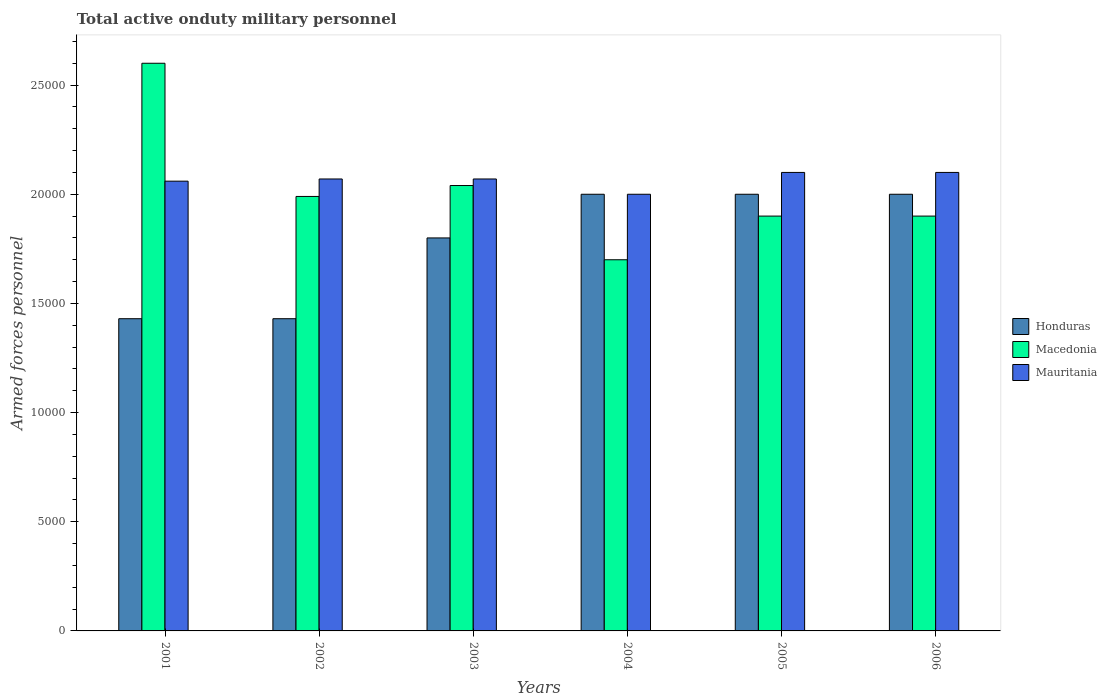How many groups of bars are there?
Provide a succinct answer. 6. How many bars are there on the 3rd tick from the left?
Offer a terse response. 3. How many bars are there on the 1st tick from the right?
Ensure brevity in your answer.  3. What is the number of armed forces personnel in Mauritania in 2002?
Offer a terse response. 2.07e+04. Across all years, what is the maximum number of armed forces personnel in Honduras?
Keep it short and to the point. 2.00e+04. Across all years, what is the minimum number of armed forces personnel in Honduras?
Make the answer very short. 1.43e+04. What is the total number of armed forces personnel in Honduras in the graph?
Provide a short and direct response. 1.07e+05. What is the difference between the number of armed forces personnel in Mauritania in 2002 and that in 2004?
Ensure brevity in your answer.  700. What is the difference between the number of armed forces personnel in Mauritania in 2006 and the number of armed forces personnel in Honduras in 2004?
Make the answer very short. 1000. What is the average number of armed forces personnel in Honduras per year?
Provide a succinct answer. 1.78e+04. In the year 2001, what is the difference between the number of armed forces personnel in Honduras and number of armed forces personnel in Macedonia?
Provide a succinct answer. -1.17e+04. What is the ratio of the number of armed forces personnel in Macedonia in 2002 to that in 2006?
Your answer should be very brief. 1.05. Is the number of armed forces personnel in Macedonia in 2002 less than that in 2006?
Ensure brevity in your answer.  No. Is the difference between the number of armed forces personnel in Honduras in 2002 and 2005 greater than the difference between the number of armed forces personnel in Macedonia in 2002 and 2005?
Keep it short and to the point. No. What is the difference between the highest and the second highest number of armed forces personnel in Macedonia?
Provide a succinct answer. 5600. What is the difference between the highest and the lowest number of armed forces personnel in Honduras?
Your response must be concise. 5700. Is the sum of the number of armed forces personnel in Mauritania in 2001 and 2004 greater than the maximum number of armed forces personnel in Macedonia across all years?
Your answer should be very brief. Yes. What does the 2nd bar from the left in 2002 represents?
Your response must be concise. Macedonia. What does the 3rd bar from the right in 2003 represents?
Offer a very short reply. Honduras. How many bars are there?
Keep it short and to the point. 18. Are all the bars in the graph horizontal?
Your answer should be compact. No. Are the values on the major ticks of Y-axis written in scientific E-notation?
Offer a terse response. No. Does the graph contain grids?
Keep it short and to the point. No. Where does the legend appear in the graph?
Provide a short and direct response. Center right. How many legend labels are there?
Your answer should be very brief. 3. What is the title of the graph?
Keep it short and to the point. Total active onduty military personnel. Does "Tonga" appear as one of the legend labels in the graph?
Your answer should be compact. No. What is the label or title of the X-axis?
Your response must be concise. Years. What is the label or title of the Y-axis?
Provide a short and direct response. Armed forces personnel. What is the Armed forces personnel of Honduras in 2001?
Provide a succinct answer. 1.43e+04. What is the Armed forces personnel of Macedonia in 2001?
Give a very brief answer. 2.60e+04. What is the Armed forces personnel of Mauritania in 2001?
Make the answer very short. 2.06e+04. What is the Armed forces personnel of Honduras in 2002?
Your answer should be very brief. 1.43e+04. What is the Armed forces personnel of Macedonia in 2002?
Your answer should be compact. 1.99e+04. What is the Armed forces personnel in Mauritania in 2002?
Offer a terse response. 2.07e+04. What is the Armed forces personnel in Honduras in 2003?
Your answer should be compact. 1.80e+04. What is the Armed forces personnel in Macedonia in 2003?
Offer a very short reply. 2.04e+04. What is the Armed forces personnel in Mauritania in 2003?
Your answer should be very brief. 2.07e+04. What is the Armed forces personnel in Macedonia in 2004?
Make the answer very short. 1.70e+04. What is the Armed forces personnel of Macedonia in 2005?
Your answer should be very brief. 1.90e+04. What is the Armed forces personnel in Mauritania in 2005?
Your answer should be compact. 2.10e+04. What is the Armed forces personnel in Honduras in 2006?
Provide a short and direct response. 2.00e+04. What is the Armed forces personnel of Macedonia in 2006?
Make the answer very short. 1.90e+04. What is the Armed forces personnel in Mauritania in 2006?
Your response must be concise. 2.10e+04. Across all years, what is the maximum Armed forces personnel of Honduras?
Provide a succinct answer. 2.00e+04. Across all years, what is the maximum Armed forces personnel of Macedonia?
Provide a succinct answer. 2.60e+04. Across all years, what is the maximum Armed forces personnel of Mauritania?
Provide a succinct answer. 2.10e+04. Across all years, what is the minimum Armed forces personnel of Honduras?
Offer a terse response. 1.43e+04. Across all years, what is the minimum Armed forces personnel of Macedonia?
Provide a succinct answer. 1.70e+04. What is the total Armed forces personnel of Honduras in the graph?
Keep it short and to the point. 1.07e+05. What is the total Armed forces personnel of Macedonia in the graph?
Your response must be concise. 1.21e+05. What is the total Armed forces personnel in Mauritania in the graph?
Your response must be concise. 1.24e+05. What is the difference between the Armed forces personnel of Macedonia in 2001 and that in 2002?
Provide a short and direct response. 6100. What is the difference between the Armed forces personnel of Mauritania in 2001 and that in 2002?
Your response must be concise. -100. What is the difference between the Armed forces personnel in Honduras in 2001 and that in 2003?
Give a very brief answer. -3700. What is the difference between the Armed forces personnel of Macedonia in 2001 and that in 2003?
Make the answer very short. 5600. What is the difference between the Armed forces personnel of Mauritania in 2001 and that in 2003?
Your answer should be very brief. -100. What is the difference between the Armed forces personnel in Honduras in 2001 and that in 2004?
Offer a terse response. -5700. What is the difference between the Armed forces personnel in Macedonia in 2001 and that in 2004?
Your answer should be compact. 9000. What is the difference between the Armed forces personnel in Mauritania in 2001 and that in 2004?
Offer a very short reply. 600. What is the difference between the Armed forces personnel of Honduras in 2001 and that in 2005?
Give a very brief answer. -5700. What is the difference between the Armed forces personnel in Macedonia in 2001 and that in 2005?
Your response must be concise. 7000. What is the difference between the Armed forces personnel of Mauritania in 2001 and that in 2005?
Ensure brevity in your answer.  -400. What is the difference between the Armed forces personnel of Honduras in 2001 and that in 2006?
Provide a succinct answer. -5700. What is the difference between the Armed forces personnel in Macedonia in 2001 and that in 2006?
Make the answer very short. 7000. What is the difference between the Armed forces personnel of Mauritania in 2001 and that in 2006?
Provide a short and direct response. -400. What is the difference between the Armed forces personnel of Honduras in 2002 and that in 2003?
Offer a terse response. -3700. What is the difference between the Armed forces personnel in Macedonia in 2002 and that in 2003?
Your answer should be compact. -500. What is the difference between the Armed forces personnel in Mauritania in 2002 and that in 2003?
Provide a succinct answer. 0. What is the difference between the Armed forces personnel of Honduras in 2002 and that in 2004?
Ensure brevity in your answer.  -5700. What is the difference between the Armed forces personnel of Macedonia in 2002 and that in 2004?
Offer a terse response. 2900. What is the difference between the Armed forces personnel in Mauritania in 2002 and that in 2004?
Offer a terse response. 700. What is the difference between the Armed forces personnel in Honduras in 2002 and that in 2005?
Your answer should be very brief. -5700. What is the difference between the Armed forces personnel of Macedonia in 2002 and that in 2005?
Make the answer very short. 900. What is the difference between the Armed forces personnel of Mauritania in 2002 and that in 2005?
Keep it short and to the point. -300. What is the difference between the Armed forces personnel in Honduras in 2002 and that in 2006?
Offer a terse response. -5700. What is the difference between the Armed forces personnel in Macedonia in 2002 and that in 2006?
Make the answer very short. 900. What is the difference between the Armed forces personnel of Mauritania in 2002 and that in 2006?
Your answer should be compact. -300. What is the difference between the Armed forces personnel in Honduras in 2003 and that in 2004?
Offer a terse response. -2000. What is the difference between the Armed forces personnel in Macedonia in 2003 and that in 2004?
Make the answer very short. 3400. What is the difference between the Armed forces personnel in Mauritania in 2003 and that in 2004?
Provide a short and direct response. 700. What is the difference between the Armed forces personnel of Honduras in 2003 and that in 2005?
Your response must be concise. -2000. What is the difference between the Armed forces personnel in Macedonia in 2003 and that in 2005?
Ensure brevity in your answer.  1400. What is the difference between the Armed forces personnel of Mauritania in 2003 and that in 2005?
Offer a very short reply. -300. What is the difference between the Armed forces personnel in Honduras in 2003 and that in 2006?
Provide a succinct answer. -2000. What is the difference between the Armed forces personnel in Macedonia in 2003 and that in 2006?
Provide a short and direct response. 1400. What is the difference between the Armed forces personnel of Mauritania in 2003 and that in 2006?
Make the answer very short. -300. What is the difference between the Armed forces personnel of Macedonia in 2004 and that in 2005?
Keep it short and to the point. -2000. What is the difference between the Armed forces personnel of Mauritania in 2004 and that in 2005?
Your response must be concise. -1000. What is the difference between the Armed forces personnel of Macedonia in 2004 and that in 2006?
Give a very brief answer. -2000. What is the difference between the Armed forces personnel of Mauritania in 2004 and that in 2006?
Give a very brief answer. -1000. What is the difference between the Armed forces personnel of Honduras in 2005 and that in 2006?
Keep it short and to the point. 0. What is the difference between the Armed forces personnel in Mauritania in 2005 and that in 2006?
Offer a very short reply. 0. What is the difference between the Armed forces personnel in Honduras in 2001 and the Armed forces personnel in Macedonia in 2002?
Provide a short and direct response. -5600. What is the difference between the Armed forces personnel in Honduras in 2001 and the Armed forces personnel in Mauritania in 2002?
Provide a short and direct response. -6400. What is the difference between the Armed forces personnel in Macedonia in 2001 and the Armed forces personnel in Mauritania in 2002?
Provide a short and direct response. 5300. What is the difference between the Armed forces personnel in Honduras in 2001 and the Armed forces personnel in Macedonia in 2003?
Your answer should be very brief. -6100. What is the difference between the Armed forces personnel in Honduras in 2001 and the Armed forces personnel in Mauritania in 2003?
Keep it short and to the point. -6400. What is the difference between the Armed forces personnel in Macedonia in 2001 and the Armed forces personnel in Mauritania in 2003?
Your answer should be compact. 5300. What is the difference between the Armed forces personnel of Honduras in 2001 and the Armed forces personnel of Macedonia in 2004?
Offer a terse response. -2700. What is the difference between the Armed forces personnel in Honduras in 2001 and the Armed forces personnel in Mauritania in 2004?
Your answer should be compact. -5700. What is the difference between the Armed forces personnel of Macedonia in 2001 and the Armed forces personnel of Mauritania in 2004?
Provide a short and direct response. 6000. What is the difference between the Armed forces personnel in Honduras in 2001 and the Armed forces personnel in Macedonia in 2005?
Make the answer very short. -4700. What is the difference between the Armed forces personnel of Honduras in 2001 and the Armed forces personnel of Mauritania in 2005?
Ensure brevity in your answer.  -6700. What is the difference between the Armed forces personnel in Honduras in 2001 and the Armed forces personnel in Macedonia in 2006?
Your answer should be compact. -4700. What is the difference between the Armed forces personnel of Honduras in 2001 and the Armed forces personnel of Mauritania in 2006?
Your answer should be compact. -6700. What is the difference between the Armed forces personnel of Honduras in 2002 and the Armed forces personnel of Macedonia in 2003?
Provide a succinct answer. -6100. What is the difference between the Armed forces personnel of Honduras in 2002 and the Armed forces personnel of Mauritania in 2003?
Give a very brief answer. -6400. What is the difference between the Armed forces personnel of Macedonia in 2002 and the Armed forces personnel of Mauritania in 2003?
Give a very brief answer. -800. What is the difference between the Armed forces personnel of Honduras in 2002 and the Armed forces personnel of Macedonia in 2004?
Offer a terse response. -2700. What is the difference between the Armed forces personnel of Honduras in 2002 and the Armed forces personnel of Mauritania in 2004?
Your response must be concise. -5700. What is the difference between the Armed forces personnel of Macedonia in 2002 and the Armed forces personnel of Mauritania in 2004?
Provide a succinct answer. -100. What is the difference between the Armed forces personnel in Honduras in 2002 and the Armed forces personnel in Macedonia in 2005?
Offer a very short reply. -4700. What is the difference between the Armed forces personnel in Honduras in 2002 and the Armed forces personnel in Mauritania in 2005?
Offer a very short reply. -6700. What is the difference between the Armed forces personnel in Macedonia in 2002 and the Armed forces personnel in Mauritania in 2005?
Give a very brief answer. -1100. What is the difference between the Armed forces personnel of Honduras in 2002 and the Armed forces personnel of Macedonia in 2006?
Make the answer very short. -4700. What is the difference between the Armed forces personnel in Honduras in 2002 and the Armed forces personnel in Mauritania in 2006?
Make the answer very short. -6700. What is the difference between the Armed forces personnel of Macedonia in 2002 and the Armed forces personnel of Mauritania in 2006?
Keep it short and to the point. -1100. What is the difference between the Armed forces personnel of Honduras in 2003 and the Armed forces personnel of Mauritania in 2004?
Your answer should be compact. -2000. What is the difference between the Armed forces personnel in Honduras in 2003 and the Armed forces personnel in Macedonia in 2005?
Make the answer very short. -1000. What is the difference between the Armed forces personnel in Honduras in 2003 and the Armed forces personnel in Mauritania in 2005?
Provide a succinct answer. -3000. What is the difference between the Armed forces personnel in Macedonia in 2003 and the Armed forces personnel in Mauritania in 2005?
Give a very brief answer. -600. What is the difference between the Armed forces personnel of Honduras in 2003 and the Armed forces personnel of Macedonia in 2006?
Provide a succinct answer. -1000. What is the difference between the Armed forces personnel of Honduras in 2003 and the Armed forces personnel of Mauritania in 2006?
Ensure brevity in your answer.  -3000. What is the difference between the Armed forces personnel of Macedonia in 2003 and the Armed forces personnel of Mauritania in 2006?
Provide a succinct answer. -600. What is the difference between the Armed forces personnel of Honduras in 2004 and the Armed forces personnel of Macedonia in 2005?
Your answer should be very brief. 1000. What is the difference between the Armed forces personnel in Honduras in 2004 and the Armed forces personnel in Mauritania in 2005?
Offer a very short reply. -1000. What is the difference between the Armed forces personnel of Macedonia in 2004 and the Armed forces personnel of Mauritania in 2005?
Make the answer very short. -4000. What is the difference between the Armed forces personnel of Honduras in 2004 and the Armed forces personnel of Macedonia in 2006?
Your response must be concise. 1000. What is the difference between the Armed forces personnel in Honduras in 2004 and the Armed forces personnel in Mauritania in 2006?
Provide a succinct answer. -1000. What is the difference between the Armed forces personnel of Macedonia in 2004 and the Armed forces personnel of Mauritania in 2006?
Your response must be concise. -4000. What is the difference between the Armed forces personnel of Honduras in 2005 and the Armed forces personnel of Macedonia in 2006?
Offer a very short reply. 1000. What is the difference between the Armed forces personnel of Honduras in 2005 and the Armed forces personnel of Mauritania in 2006?
Provide a succinct answer. -1000. What is the difference between the Armed forces personnel in Macedonia in 2005 and the Armed forces personnel in Mauritania in 2006?
Provide a succinct answer. -2000. What is the average Armed forces personnel in Honduras per year?
Give a very brief answer. 1.78e+04. What is the average Armed forces personnel of Macedonia per year?
Give a very brief answer. 2.02e+04. What is the average Armed forces personnel in Mauritania per year?
Provide a short and direct response. 2.07e+04. In the year 2001, what is the difference between the Armed forces personnel of Honduras and Armed forces personnel of Macedonia?
Provide a succinct answer. -1.17e+04. In the year 2001, what is the difference between the Armed forces personnel in Honduras and Armed forces personnel in Mauritania?
Provide a succinct answer. -6300. In the year 2001, what is the difference between the Armed forces personnel of Macedonia and Armed forces personnel of Mauritania?
Your response must be concise. 5400. In the year 2002, what is the difference between the Armed forces personnel in Honduras and Armed forces personnel in Macedonia?
Provide a succinct answer. -5600. In the year 2002, what is the difference between the Armed forces personnel in Honduras and Armed forces personnel in Mauritania?
Your answer should be very brief. -6400. In the year 2002, what is the difference between the Armed forces personnel of Macedonia and Armed forces personnel of Mauritania?
Give a very brief answer. -800. In the year 2003, what is the difference between the Armed forces personnel in Honduras and Armed forces personnel in Macedonia?
Your answer should be compact. -2400. In the year 2003, what is the difference between the Armed forces personnel in Honduras and Armed forces personnel in Mauritania?
Keep it short and to the point. -2700. In the year 2003, what is the difference between the Armed forces personnel of Macedonia and Armed forces personnel of Mauritania?
Keep it short and to the point. -300. In the year 2004, what is the difference between the Armed forces personnel in Honduras and Armed forces personnel in Macedonia?
Offer a very short reply. 3000. In the year 2004, what is the difference between the Armed forces personnel in Honduras and Armed forces personnel in Mauritania?
Offer a very short reply. 0. In the year 2004, what is the difference between the Armed forces personnel in Macedonia and Armed forces personnel in Mauritania?
Keep it short and to the point. -3000. In the year 2005, what is the difference between the Armed forces personnel of Honduras and Armed forces personnel of Mauritania?
Give a very brief answer. -1000. In the year 2005, what is the difference between the Armed forces personnel of Macedonia and Armed forces personnel of Mauritania?
Your response must be concise. -2000. In the year 2006, what is the difference between the Armed forces personnel of Honduras and Armed forces personnel of Macedonia?
Offer a terse response. 1000. In the year 2006, what is the difference between the Armed forces personnel of Honduras and Armed forces personnel of Mauritania?
Your response must be concise. -1000. In the year 2006, what is the difference between the Armed forces personnel of Macedonia and Armed forces personnel of Mauritania?
Your response must be concise. -2000. What is the ratio of the Armed forces personnel in Honduras in 2001 to that in 2002?
Your answer should be very brief. 1. What is the ratio of the Armed forces personnel of Macedonia in 2001 to that in 2002?
Make the answer very short. 1.31. What is the ratio of the Armed forces personnel of Mauritania in 2001 to that in 2002?
Your response must be concise. 1. What is the ratio of the Armed forces personnel in Honduras in 2001 to that in 2003?
Offer a terse response. 0.79. What is the ratio of the Armed forces personnel in Macedonia in 2001 to that in 2003?
Ensure brevity in your answer.  1.27. What is the ratio of the Armed forces personnel in Mauritania in 2001 to that in 2003?
Keep it short and to the point. 1. What is the ratio of the Armed forces personnel in Honduras in 2001 to that in 2004?
Your answer should be compact. 0.71. What is the ratio of the Armed forces personnel in Macedonia in 2001 to that in 2004?
Make the answer very short. 1.53. What is the ratio of the Armed forces personnel in Mauritania in 2001 to that in 2004?
Provide a short and direct response. 1.03. What is the ratio of the Armed forces personnel in Honduras in 2001 to that in 2005?
Provide a succinct answer. 0.71. What is the ratio of the Armed forces personnel in Macedonia in 2001 to that in 2005?
Offer a terse response. 1.37. What is the ratio of the Armed forces personnel of Mauritania in 2001 to that in 2005?
Provide a short and direct response. 0.98. What is the ratio of the Armed forces personnel of Honduras in 2001 to that in 2006?
Offer a very short reply. 0.71. What is the ratio of the Armed forces personnel in Macedonia in 2001 to that in 2006?
Provide a succinct answer. 1.37. What is the ratio of the Armed forces personnel of Mauritania in 2001 to that in 2006?
Your response must be concise. 0.98. What is the ratio of the Armed forces personnel of Honduras in 2002 to that in 2003?
Offer a very short reply. 0.79. What is the ratio of the Armed forces personnel in Macedonia in 2002 to that in 2003?
Your response must be concise. 0.98. What is the ratio of the Armed forces personnel in Honduras in 2002 to that in 2004?
Give a very brief answer. 0.71. What is the ratio of the Armed forces personnel of Macedonia in 2002 to that in 2004?
Your answer should be very brief. 1.17. What is the ratio of the Armed forces personnel of Mauritania in 2002 to that in 2004?
Offer a very short reply. 1.03. What is the ratio of the Armed forces personnel of Honduras in 2002 to that in 2005?
Make the answer very short. 0.71. What is the ratio of the Armed forces personnel in Macedonia in 2002 to that in 2005?
Your answer should be very brief. 1.05. What is the ratio of the Armed forces personnel of Mauritania in 2002 to that in 2005?
Ensure brevity in your answer.  0.99. What is the ratio of the Armed forces personnel of Honduras in 2002 to that in 2006?
Your answer should be compact. 0.71. What is the ratio of the Armed forces personnel of Macedonia in 2002 to that in 2006?
Keep it short and to the point. 1.05. What is the ratio of the Armed forces personnel of Mauritania in 2002 to that in 2006?
Keep it short and to the point. 0.99. What is the ratio of the Armed forces personnel in Mauritania in 2003 to that in 2004?
Your answer should be very brief. 1.03. What is the ratio of the Armed forces personnel in Macedonia in 2003 to that in 2005?
Offer a very short reply. 1.07. What is the ratio of the Armed forces personnel of Mauritania in 2003 to that in 2005?
Make the answer very short. 0.99. What is the ratio of the Armed forces personnel in Honduras in 2003 to that in 2006?
Keep it short and to the point. 0.9. What is the ratio of the Armed forces personnel of Macedonia in 2003 to that in 2006?
Make the answer very short. 1.07. What is the ratio of the Armed forces personnel in Mauritania in 2003 to that in 2006?
Provide a succinct answer. 0.99. What is the ratio of the Armed forces personnel in Honduras in 2004 to that in 2005?
Offer a terse response. 1. What is the ratio of the Armed forces personnel in Macedonia in 2004 to that in 2005?
Offer a terse response. 0.89. What is the ratio of the Armed forces personnel of Mauritania in 2004 to that in 2005?
Keep it short and to the point. 0.95. What is the ratio of the Armed forces personnel of Honduras in 2004 to that in 2006?
Ensure brevity in your answer.  1. What is the ratio of the Armed forces personnel in Macedonia in 2004 to that in 2006?
Provide a succinct answer. 0.89. What is the ratio of the Armed forces personnel of Macedonia in 2005 to that in 2006?
Offer a terse response. 1. What is the difference between the highest and the second highest Armed forces personnel in Macedonia?
Give a very brief answer. 5600. What is the difference between the highest and the lowest Armed forces personnel in Honduras?
Give a very brief answer. 5700. What is the difference between the highest and the lowest Armed forces personnel of Macedonia?
Offer a very short reply. 9000. What is the difference between the highest and the lowest Armed forces personnel of Mauritania?
Provide a short and direct response. 1000. 